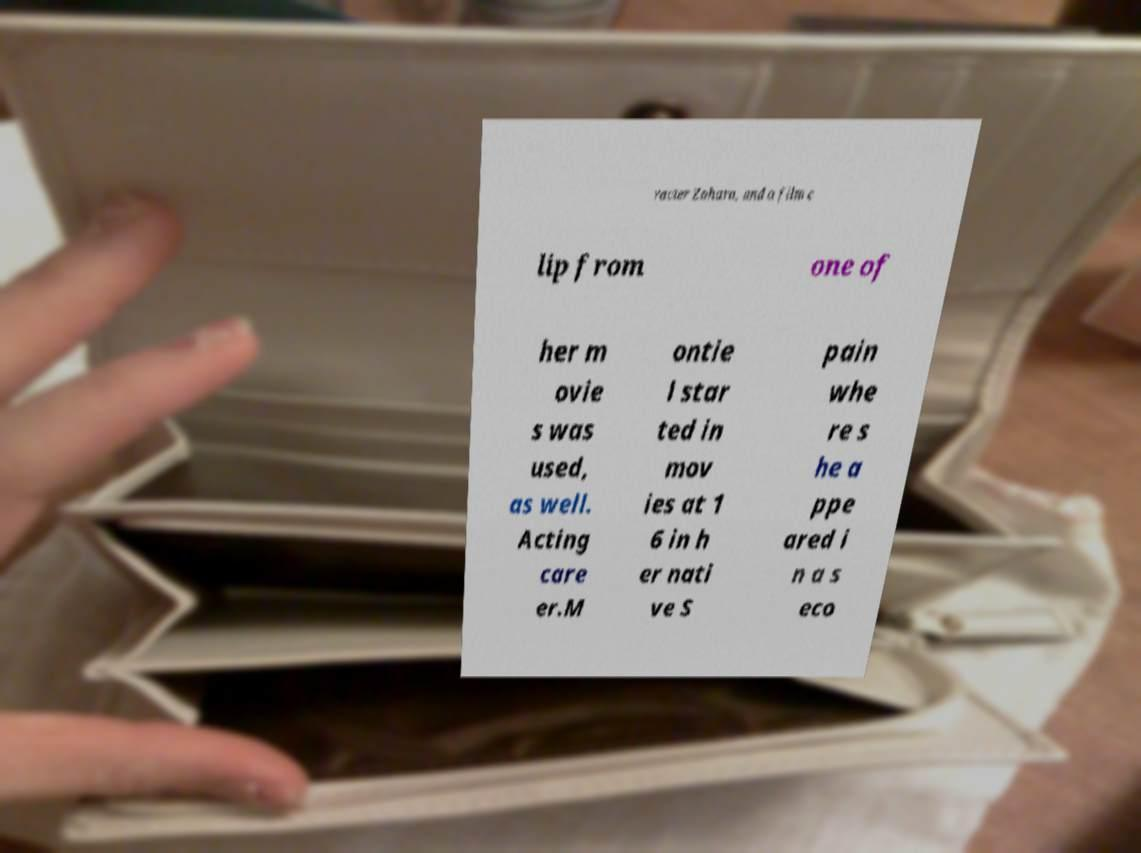Could you assist in decoding the text presented in this image and type it out clearly? racter Zahara, and a film c lip from one of her m ovie s was used, as well. Acting care er.M ontie l star ted in mov ies at 1 6 in h er nati ve S pain whe re s he a ppe ared i n a s eco 